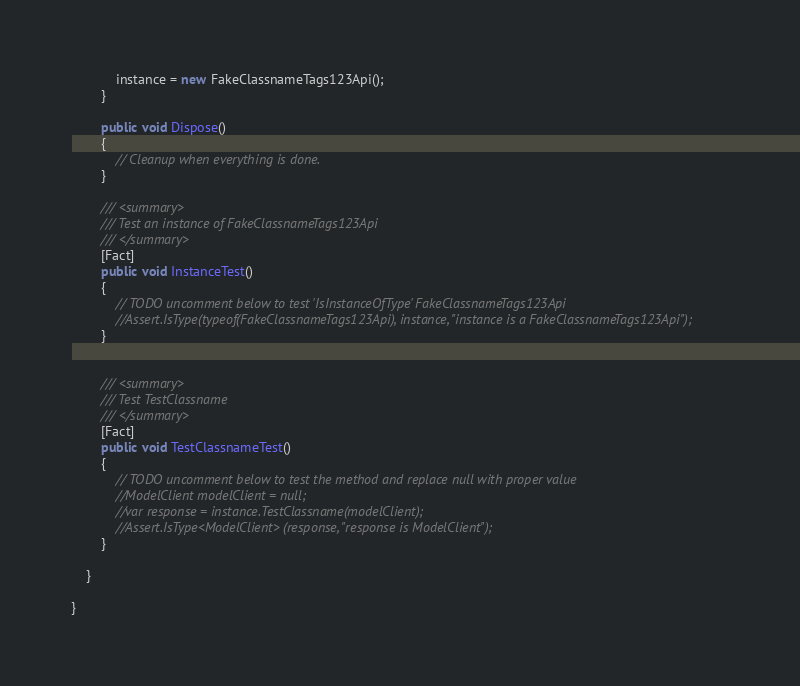Convert code to text. <code><loc_0><loc_0><loc_500><loc_500><_C#_>            instance = new FakeClassnameTags123Api();
        }

        public void Dispose()
        {
            // Cleanup when everything is done.
        }

        /// <summary>
        /// Test an instance of FakeClassnameTags123Api
        /// </summary>
        [Fact]
        public void InstanceTest()
        {
            // TODO uncomment below to test 'IsInstanceOfType' FakeClassnameTags123Api
            //Assert.IsType(typeof(FakeClassnameTags123Api), instance, "instance is a FakeClassnameTags123Api");
        }

        
        /// <summary>
        /// Test TestClassname
        /// </summary>
        [Fact]
        public void TestClassnameTest()
        {
            // TODO uncomment below to test the method and replace null with proper value
            //ModelClient modelClient = null;
            //var response = instance.TestClassname(modelClient);
            //Assert.IsType<ModelClient> (response, "response is ModelClient");
        }
        
    }

}
</code> 